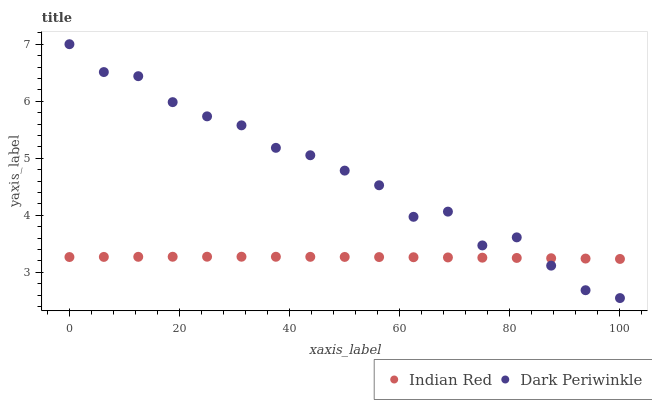Does Indian Red have the minimum area under the curve?
Answer yes or no. Yes. Does Dark Periwinkle have the maximum area under the curve?
Answer yes or no. Yes. Does Indian Red have the maximum area under the curve?
Answer yes or no. No. Is Indian Red the smoothest?
Answer yes or no. Yes. Is Dark Periwinkle the roughest?
Answer yes or no. Yes. Is Indian Red the roughest?
Answer yes or no. No. Does Dark Periwinkle have the lowest value?
Answer yes or no. Yes. Does Indian Red have the lowest value?
Answer yes or no. No. Does Dark Periwinkle have the highest value?
Answer yes or no. Yes. Does Indian Red have the highest value?
Answer yes or no. No. Does Dark Periwinkle intersect Indian Red?
Answer yes or no. Yes. Is Dark Periwinkle less than Indian Red?
Answer yes or no. No. Is Dark Periwinkle greater than Indian Red?
Answer yes or no. No. 